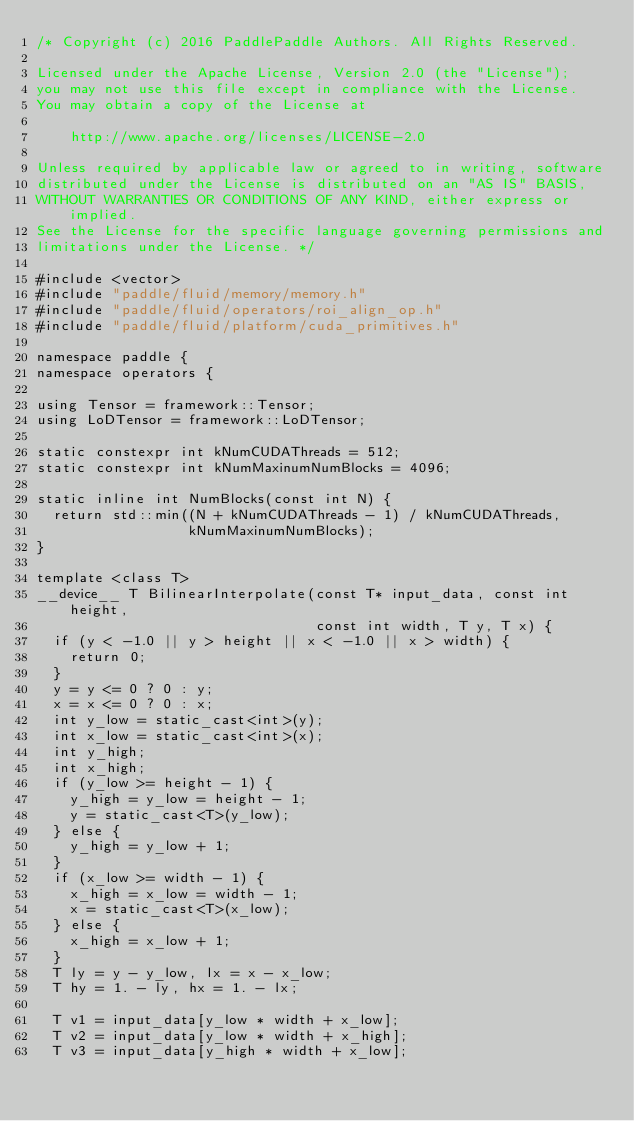<code> <loc_0><loc_0><loc_500><loc_500><_Cuda_>/* Copyright (c) 2016 PaddlePaddle Authors. All Rights Reserved.

Licensed under the Apache License, Version 2.0 (the "License");
you may not use this file except in compliance with the License.
You may obtain a copy of the License at

    http://www.apache.org/licenses/LICENSE-2.0

Unless required by applicable law or agreed to in writing, software
distributed under the License is distributed on an "AS IS" BASIS,
WITHOUT WARRANTIES OR CONDITIONS OF ANY KIND, either express or implied.
See the License for the specific language governing permissions and
limitations under the License. */

#include <vector>
#include "paddle/fluid/memory/memory.h"
#include "paddle/fluid/operators/roi_align_op.h"
#include "paddle/fluid/platform/cuda_primitives.h"

namespace paddle {
namespace operators {

using Tensor = framework::Tensor;
using LoDTensor = framework::LoDTensor;

static constexpr int kNumCUDAThreads = 512;
static constexpr int kNumMaxinumNumBlocks = 4096;

static inline int NumBlocks(const int N) {
  return std::min((N + kNumCUDAThreads - 1) / kNumCUDAThreads,
                  kNumMaxinumNumBlocks);
}

template <class T>
__device__ T BilinearInterpolate(const T* input_data, const int height,
                                 const int width, T y, T x) {
  if (y < -1.0 || y > height || x < -1.0 || x > width) {
    return 0;
  }
  y = y <= 0 ? 0 : y;
  x = x <= 0 ? 0 : x;
  int y_low = static_cast<int>(y);
  int x_low = static_cast<int>(x);
  int y_high;
  int x_high;
  if (y_low >= height - 1) {
    y_high = y_low = height - 1;
    y = static_cast<T>(y_low);
  } else {
    y_high = y_low + 1;
  }
  if (x_low >= width - 1) {
    x_high = x_low = width - 1;
    x = static_cast<T>(x_low);
  } else {
    x_high = x_low + 1;
  }
  T ly = y - y_low, lx = x - x_low;
  T hy = 1. - ly, hx = 1. - lx;

  T v1 = input_data[y_low * width + x_low];
  T v2 = input_data[y_low * width + x_high];
  T v3 = input_data[y_high * width + x_low];</code> 